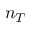Convert formula to latex. <formula><loc_0><loc_0><loc_500><loc_500>n _ { T }</formula> 